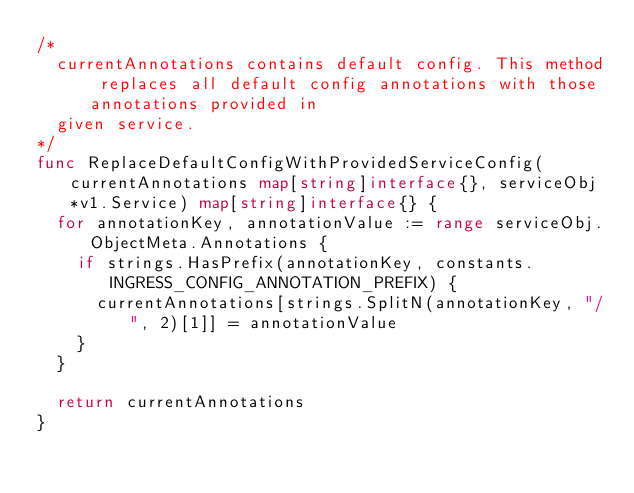<code> <loc_0><loc_0><loc_500><loc_500><_Go_>/*
	currentAnnotations contains default config. This method replaces all default config annotations with those annotations provided in
	given service.
*/
func ReplaceDefaultConfigWithProvidedServiceConfig(currentAnnotations map[string]interface{}, serviceObj *v1.Service) map[string]interface{} {
	for annotationKey, annotationValue := range serviceObj.ObjectMeta.Annotations {
		if strings.HasPrefix(annotationKey, constants.INGRESS_CONFIG_ANNOTATION_PREFIX) {
			currentAnnotations[strings.SplitN(annotationKey, "/", 2)[1]] = annotationValue
		}
	}

	return currentAnnotations
}
</code> 